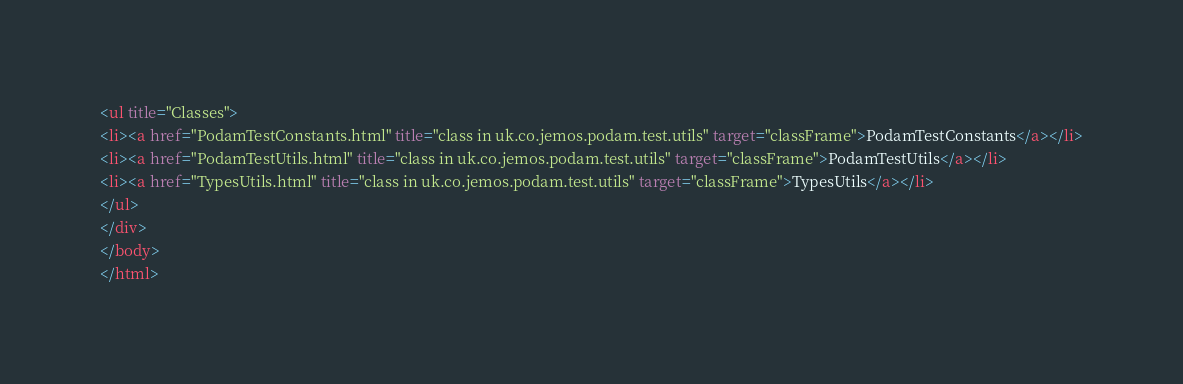<code> <loc_0><loc_0><loc_500><loc_500><_HTML_><ul title="Classes">
<li><a href="PodamTestConstants.html" title="class in uk.co.jemos.podam.test.utils" target="classFrame">PodamTestConstants</a></li>
<li><a href="PodamTestUtils.html" title="class in uk.co.jemos.podam.test.utils" target="classFrame">PodamTestUtils</a></li>
<li><a href="TypesUtils.html" title="class in uk.co.jemos.podam.test.utils" target="classFrame">TypesUtils</a></li>
</ul>
</div>
</body>
</html>
</code> 